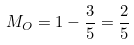<formula> <loc_0><loc_0><loc_500><loc_500>M _ { O } = 1 - \frac { 3 } { 5 } = \frac { 2 } { 5 }</formula> 